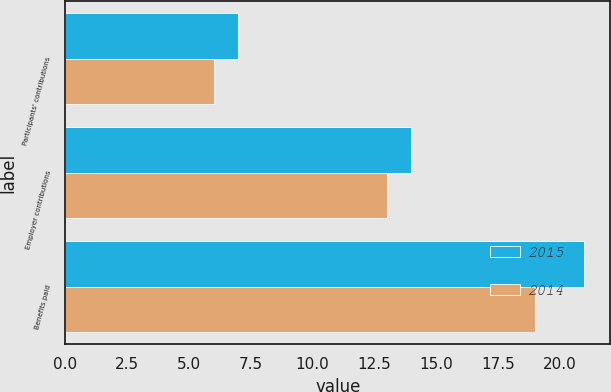Convert chart. <chart><loc_0><loc_0><loc_500><loc_500><stacked_bar_chart><ecel><fcel>Participants' contributions<fcel>Employer contributions<fcel>Benefits paid<nl><fcel>2015<fcel>7<fcel>14<fcel>21<nl><fcel>2014<fcel>6<fcel>13<fcel>19<nl></chart> 